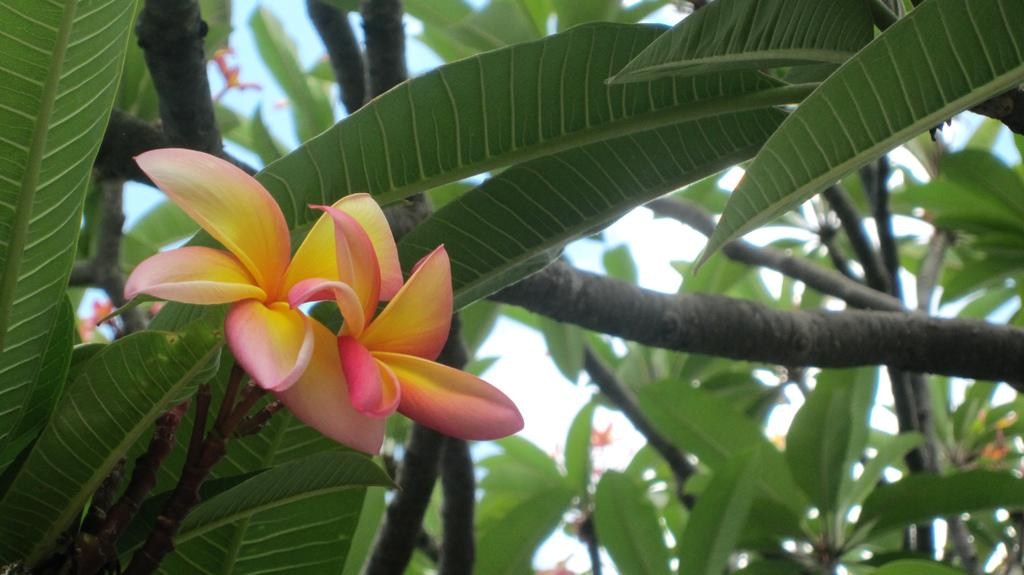What is the main subject of the image? The main subject of the image is a flower. Can you describe the colors of the flower? The flower has pink and yellow colors. Where is the flower located? The flower is on a tree. What can be seen in the background of the image? There are trees and the sky visible in the background of the image. How much debt does the flower have in the image? There is no information about debt in the image, as it features a flower on a tree with a background of trees and the sky. 